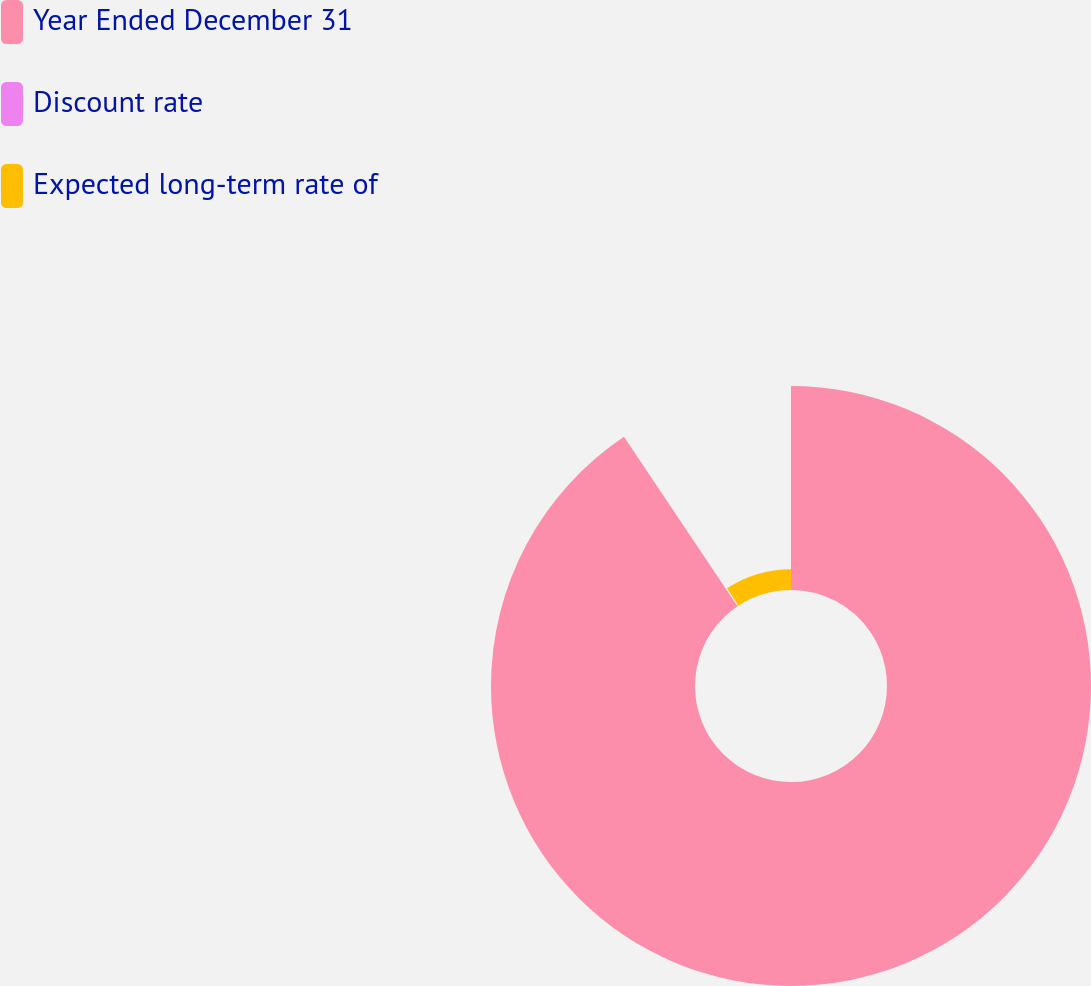<chart> <loc_0><loc_0><loc_500><loc_500><pie_chart><fcel>Year Ended December 31<fcel>Discount rate<fcel>Expected long-term rate of<nl><fcel>90.6%<fcel>0.18%<fcel>9.22%<nl></chart> 